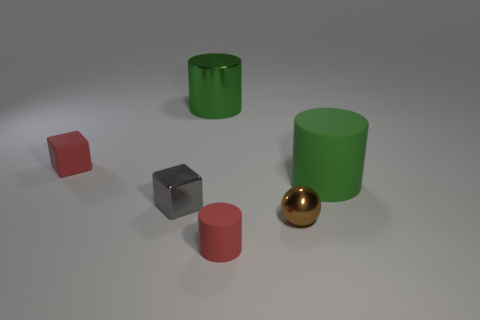Do the objects have shadows, and if so, what does that tell us about the lighting in the scene? Yes, each object casts a shadow, indicating that there is a single light source in the scene which appears to be located above and to the left of the objects, creating soft shadows and giving depth to the image. 